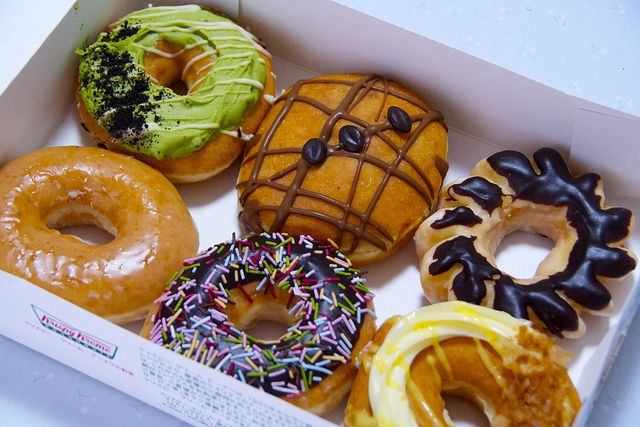Describe the objects in this image and their specific colors. I can see donut in lavender, olive, maroon, and black tones, donut in lavender, black, olive, gray, and tan tones, donut in lavender, black, maroon, olive, and gray tones, donut in lavender, olive, black, and khaki tones, and donut in lavender, orange, and tan tones in this image. 